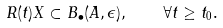<formula> <loc_0><loc_0><loc_500><loc_500>R ( t ) X \subset B _ { \bullet } ( A , \epsilon ) , \quad \forall t \geq t _ { 0 } .</formula> 